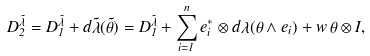<formula> <loc_0><loc_0><loc_500><loc_500>D _ { 2 } ^ { \tilde { \lambda } } = D _ { 1 } ^ { \tilde { \lambda } } + d \tilde { \lambda } ( \tilde { \theta } ) = D _ { 1 } ^ { \tilde { \lambda } } + \sum _ { i = 1 } ^ { n } e _ { i } ^ { * } \otimes d \lambda ( \theta \wedge e _ { i } ) + w \, \theta \otimes I ,</formula> 